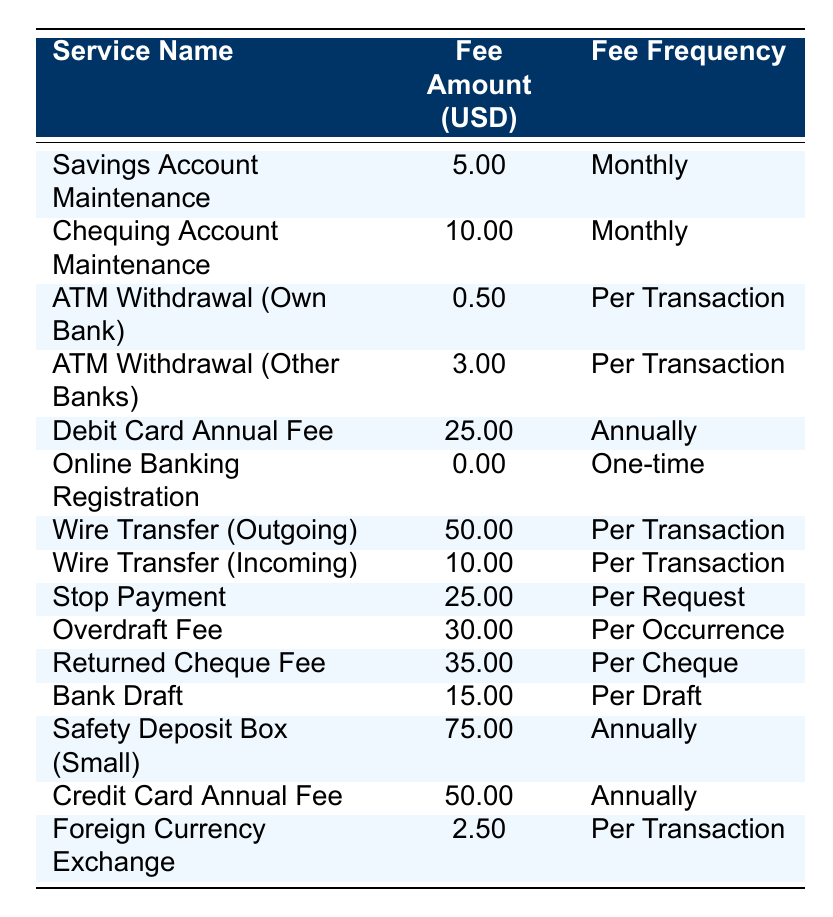What is the fee for ATM withdrawals at the bank's own ATMs? The table shows that the fee for ATM Withdrawal (Own Bank) is 0.50 USD per transaction.
Answer: 0.50 USD What is the monthly maintenance fee for a chequing account? According to the table, the fee for Chequing Account Maintenance is 10.00 USD monthly.
Answer: 10.00 USD How much does it cost to stop a payment? The table specifies that the fee for Stop Payment is 25.00 USD per request.
Answer: 25.00 USD What is the total annual fee for a debit card and a credit card? The Debit Card Annual Fee is 25.00 USD and the Credit Card Annual Fee is 50.00 USD. Adding these gives 25.00 + 50.00 = 75.00 USD.
Answer: 75.00 USD How much do I pay annually for a Safety Deposit Box (Small)? The table states that the fee for Safety Deposit Box (Small) is 75.00 USD annually.
Answer: 75.00 USD Is the online banking registration fee free? Yes, the table indicates that the fee for Online Banking Registration is 0.00 USD, meaning there is no charge.
Answer: Yes What is the fee difference between a wire transfer outgoing and an incoming transfer? The fee for Wire Transfer (Outgoing) is 50.00 USD and for Wire Transfer (Incoming) is 10.00 USD. The difference is 50.00 - 10.00 = 40.00 USD.
Answer: 40.00 USD What is the total cost if I make three ATM withdrawals (other banks) and one wire transfer outgoing? The fee for ATM Withdrawal (Other Banks) is 3.00 USD per transaction, so for three withdrawals, it costs 3.00 * 3 = 9.00 USD. The outgoing wire transfer costs 50.00 USD. The total is 9.00 + 50.00 = 59.00 USD.
Answer: 59.00 USD If I exchange foreign currency 5 times, how much will it cost me in total? The fee for Foreign Currency Exchange is 2.50 USD per transaction. For 5 transactions, it costs 2.50 * 5 = 12.50 USD.
Answer: 12.50 USD How much is the fee for a returned cheque? The table shows that the Returned Cheque Fee is 35.00 USD per cheque.
Answer: 35.00 USD What is the median fee amount for the services listed? The fee amounts are as follows: 5.00, 10.00, 0.50, 3.00, 25.00, 0.00, 50.00, 10.00, 25.00, 30.00, 35.00, 15.00, 75.00, 50.00, 2.50. Arranging them results in this list: 0.00, 0.50, 2.50, 3.00, 5.00, 10.00, 15.00, 25.00, 25.00, 30.00, 35.00, 50.00, 50.00, 75.00. With 15 fees, the median is the 8th value, which is 25.00 USD.
Answer: 25.00 USD 